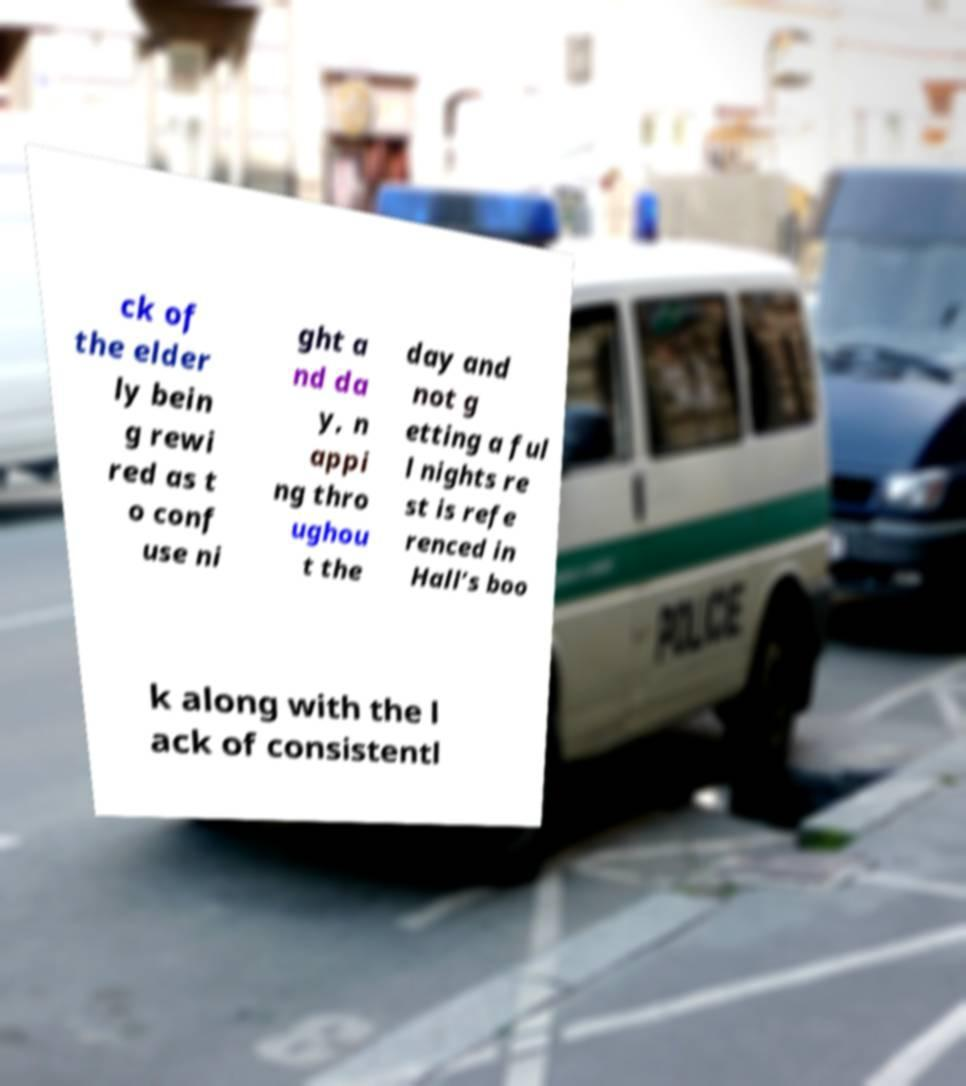What messages or text are displayed in this image? I need them in a readable, typed format. ck of the elder ly bein g rewi red as t o conf use ni ght a nd da y, n appi ng thro ughou t the day and not g etting a ful l nights re st is refe renced in Hall’s boo k along with the l ack of consistentl 